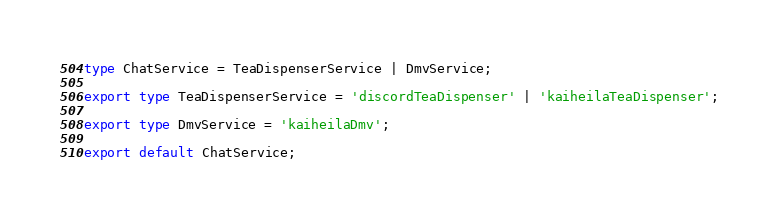Convert code to text. <code><loc_0><loc_0><loc_500><loc_500><_TypeScript_>type ChatService = TeaDispenserService | DmvService;

export type TeaDispenserService = 'discordTeaDispenser' | 'kaiheilaTeaDispenser';

export type DmvService = 'kaiheilaDmv';

export default ChatService;
</code> 